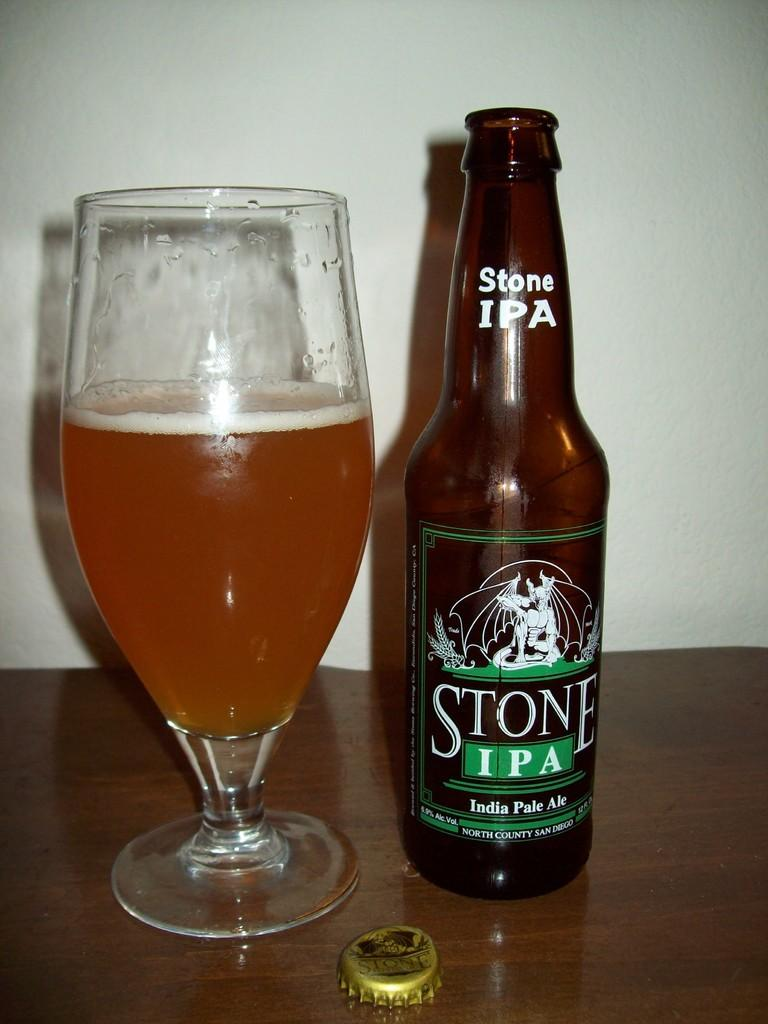Provide a one-sentence caption for the provided image. A bottle of Stone IPA next to a half full glass. 